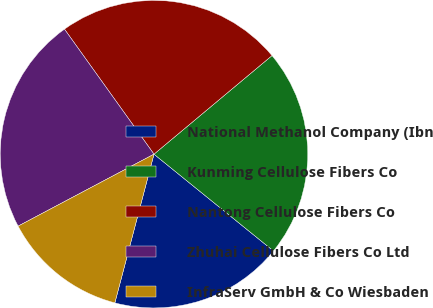<chart> <loc_0><loc_0><loc_500><loc_500><pie_chart><fcel>National Methanol Company (Ibn<fcel>Kunming Cellulose Fibers Co<fcel>Nantong Cellulose Fibers Co<fcel>Zhuhai Cellulose Fibers Co Ltd<fcel>InfraServ GmbH & Co Wiesbaden<nl><fcel>18.26%<fcel>21.91%<fcel>23.81%<fcel>22.86%<fcel>13.15%<nl></chart> 